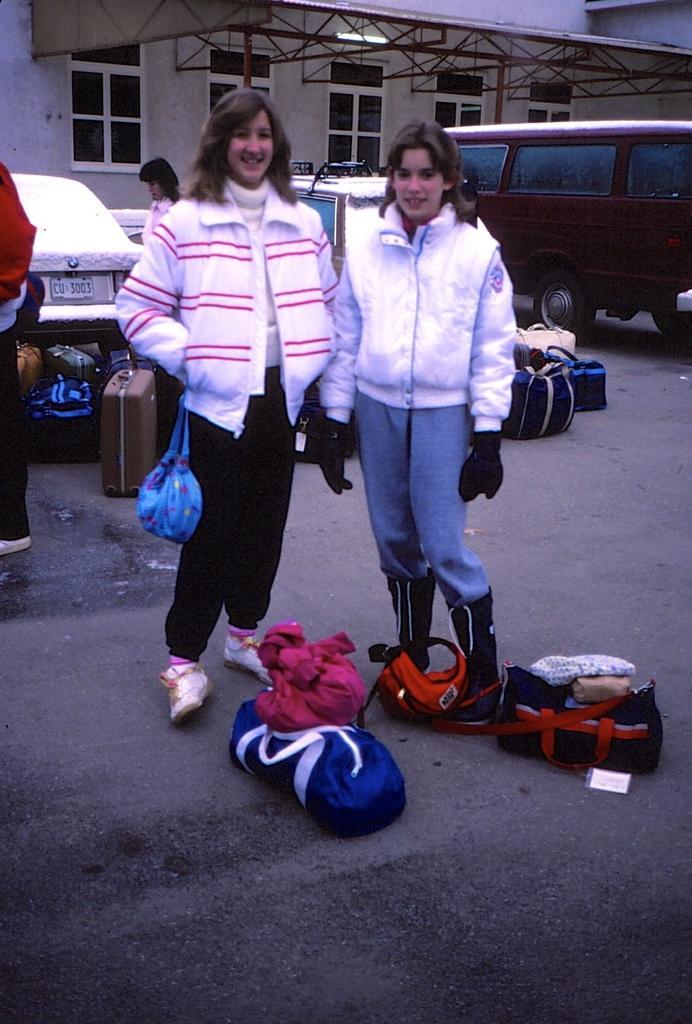Please provide a concise description of this image. In this picture, we can see a few people and one of them are carrying a bag, and we can see some vehicles, and some objects on the road, in the background we can see a wall with windows and shed. 